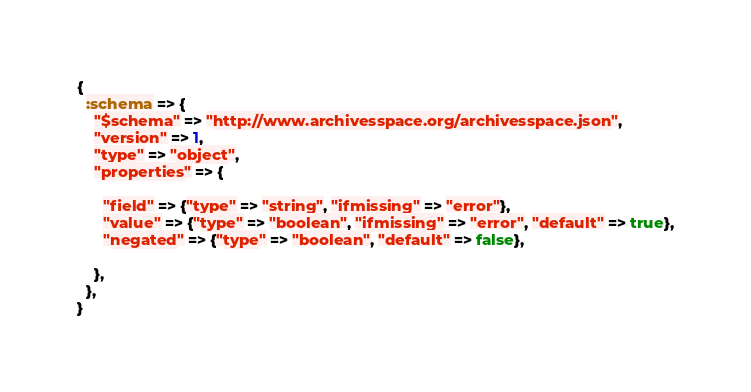Convert code to text. <code><loc_0><loc_0><loc_500><loc_500><_Ruby_>{
  :schema => {
    "$schema" => "http://www.archivesspace.org/archivesspace.json",
    "version" => 1,
    "type" => "object",
    "properties" => {

      "field" => {"type" => "string", "ifmissing" => "error"},
      "value" => {"type" => "boolean", "ifmissing" => "error", "default" => true},
      "negated" => {"type" => "boolean", "default" => false},

    },
  },
}
</code> 